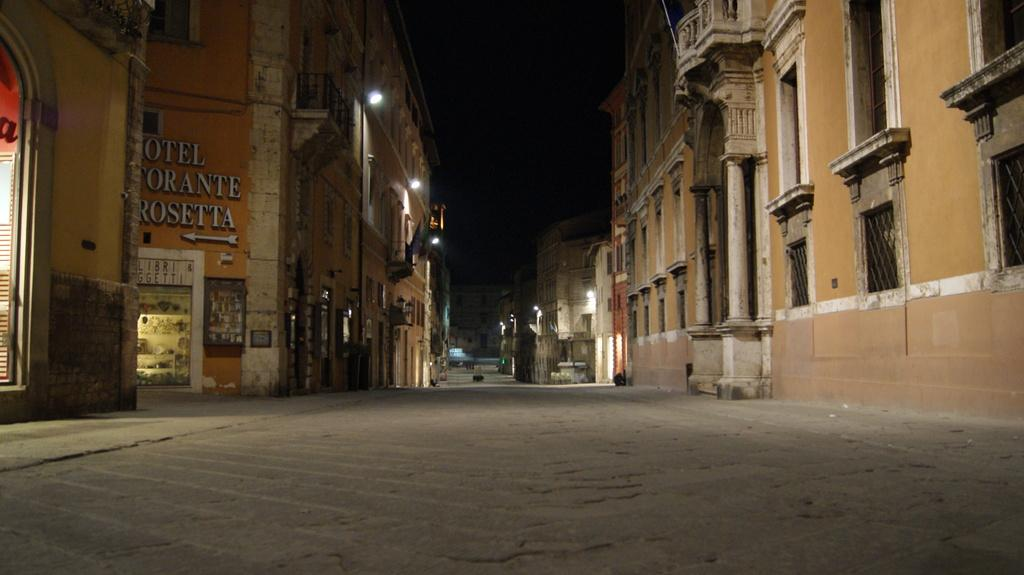Where was the image taken? The image was clicked outside. What can be seen on the left side of the image? There are buildings on the left side of the image, and it appears to be a store. What is present on the right side of the image? There are buildings on the right side of the image. What is located in the middle of the image? There are lights in the middle of the image. How many zinc elements can be seen in the image? There is no mention of zinc elements in the image, so it is not possible to determine their presence or quantity. 